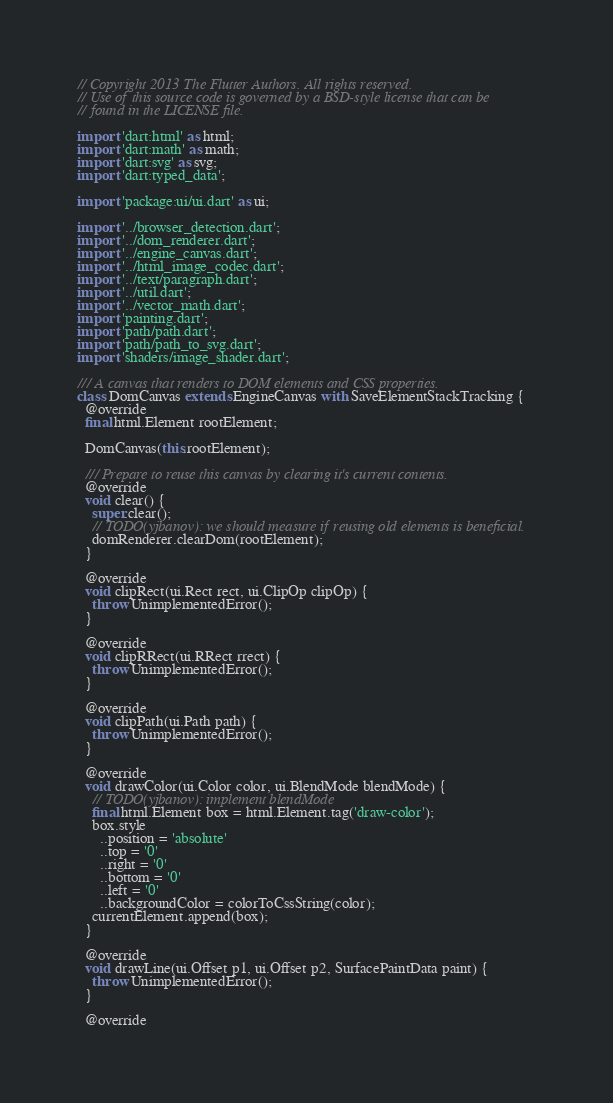<code> <loc_0><loc_0><loc_500><loc_500><_Dart_>// Copyright 2013 The Flutter Authors. All rights reserved.
// Use of this source code is governed by a BSD-style license that can be
// found in the LICENSE file.

import 'dart:html' as html;
import 'dart:math' as math;
import 'dart:svg' as svg;
import 'dart:typed_data';

import 'package:ui/ui.dart' as ui;

import '../browser_detection.dart';
import '../dom_renderer.dart';
import '../engine_canvas.dart';
import '../html_image_codec.dart';
import '../text/paragraph.dart';
import '../util.dart';
import '../vector_math.dart';
import 'painting.dart';
import 'path/path.dart';
import 'path/path_to_svg.dart';
import 'shaders/image_shader.dart';

/// A canvas that renders to DOM elements and CSS properties.
class DomCanvas extends EngineCanvas with SaveElementStackTracking {
  @override
  final html.Element rootElement;

  DomCanvas(this.rootElement);

  /// Prepare to reuse this canvas by clearing it's current contents.
  @override
  void clear() {
    super.clear();
    // TODO(yjbanov): we should measure if reusing old elements is beneficial.
    domRenderer.clearDom(rootElement);
  }

  @override
  void clipRect(ui.Rect rect, ui.ClipOp clipOp) {
    throw UnimplementedError();
  }

  @override
  void clipRRect(ui.RRect rrect) {
    throw UnimplementedError();
  }

  @override
  void clipPath(ui.Path path) {
    throw UnimplementedError();
  }

  @override
  void drawColor(ui.Color color, ui.BlendMode blendMode) {
    // TODO(yjbanov): implement blendMode
    final html.Element box = html.Element.tag('draw-color');
    box.style
      ..position = 'absolute'
      ..top = '0'
      ..right = '0'
      ..bottom = '0'
      ..left = '0'
      ..backgroundColor = colorToCssString(color);
    currentElement.append(box);
  }

  @override
  void drawLine(ui.Offset p1, ui.Offset p2, SurfacePaintData paint) {
    throw UnimplementedError();
  }

  @override</code> 